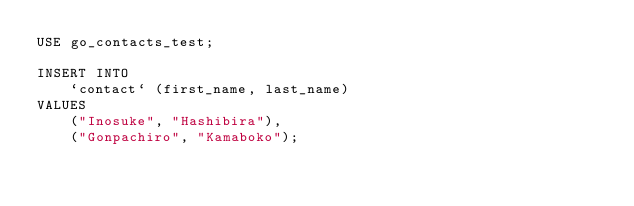Convert code to text. <code><loc_0><loc_0><loc_500><loc_500><_SQL_>USE go_contacts_test;

INSERT INTO 
    `contact` (first_name, last_name) 
VALUES 
    ("Inosuke", "Hashibira"),
    ("Gonpachiro", "Kamaboko");</code> 